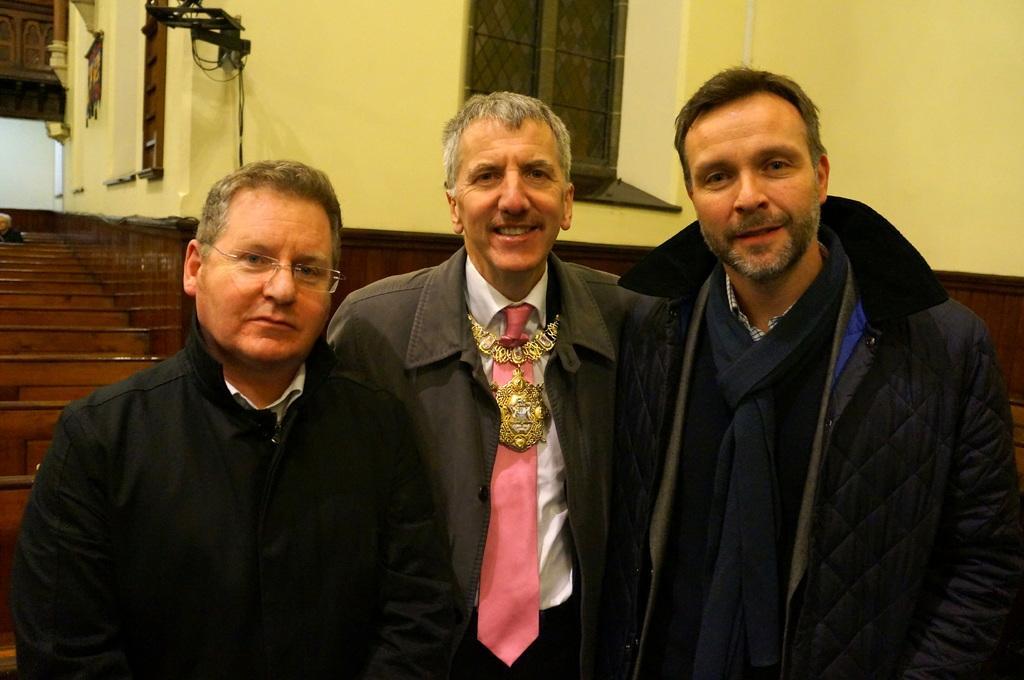Please provide a concise description of this image. Men are standing wearing black color clothes, this is well with the window. 